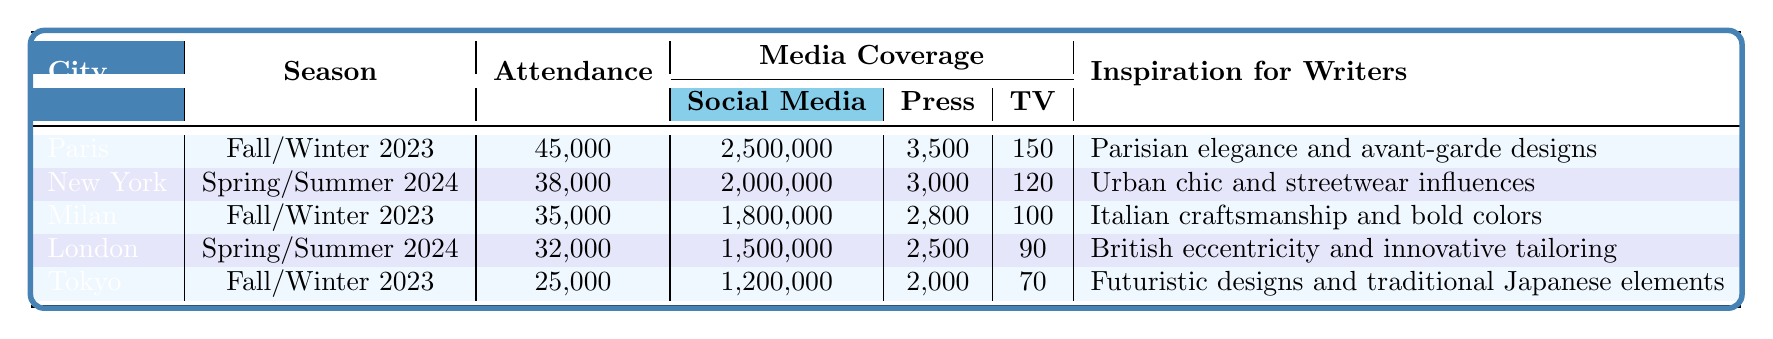What city had the highest attendance at the fashion week? The attendance figures listed for each city can be compared directly. Paris has the highest attendance at 45,000.
Answer: Paris How many media coverage articles were published for Milan? The table shows that Milan had 2,800 press articles during its fashion week.
Answer: 2800 What is the total number of social media mentions across all cities? To find the total, add the social media mentions from each city: 2,500,000 + 2,000,000 + 1,800,000 + 1,500,000 + 1,200,000 = 10,000,000.
Answer: 10,000,000 Is the inspiration for writers in New York related to urban fashion themes? The inspiration listed for New York is "Urban chic and streetwear influences," confirming that it is related to urban fashion themes.
Answer: Yes Which city had the least amount of TV broadcasts during its fashion week? The table indicates that Tokyo had the least TV broadcasts, with a total of 70.
Answer: Tokyo What is the average attendance of the fashion weeks listed in the table? To find the average, first sum the attendance figures: 45,000 + 38,000 + 35,000 + 32,000 + 25,000 = 175,000. Then divide by the 5 cities: 175,000 / 5 = 35,000.
Answer: 35,000 Did Milan have more media coverage in terms of social media mentions than London? The social media mentions for Milan are 1,800,000 and for London, 1,500,000, so Milan did indeed have more mentions.
Answer: Yes What is the difference in attendance between Paris and Tokyo? The attendance numbers show Paris at 45,000 and Tokyo at 25,000. The difference is 45,000 - 25,000 = 20,000.
Answer: 20,000 Which city features designers known for their luxurious craftsmanship and bold colors? The notable designers in Milan, such as Gucci and Prada, are known for their craftsmanship and bold colors.
Answer: Milan How many more press articles were published in Paris compared to Tokyo? Paris had 3,500 press articles and Tokyo had 2,000. The difference is 3,500 - 2,000 = 1,500.
Answer: 1500 